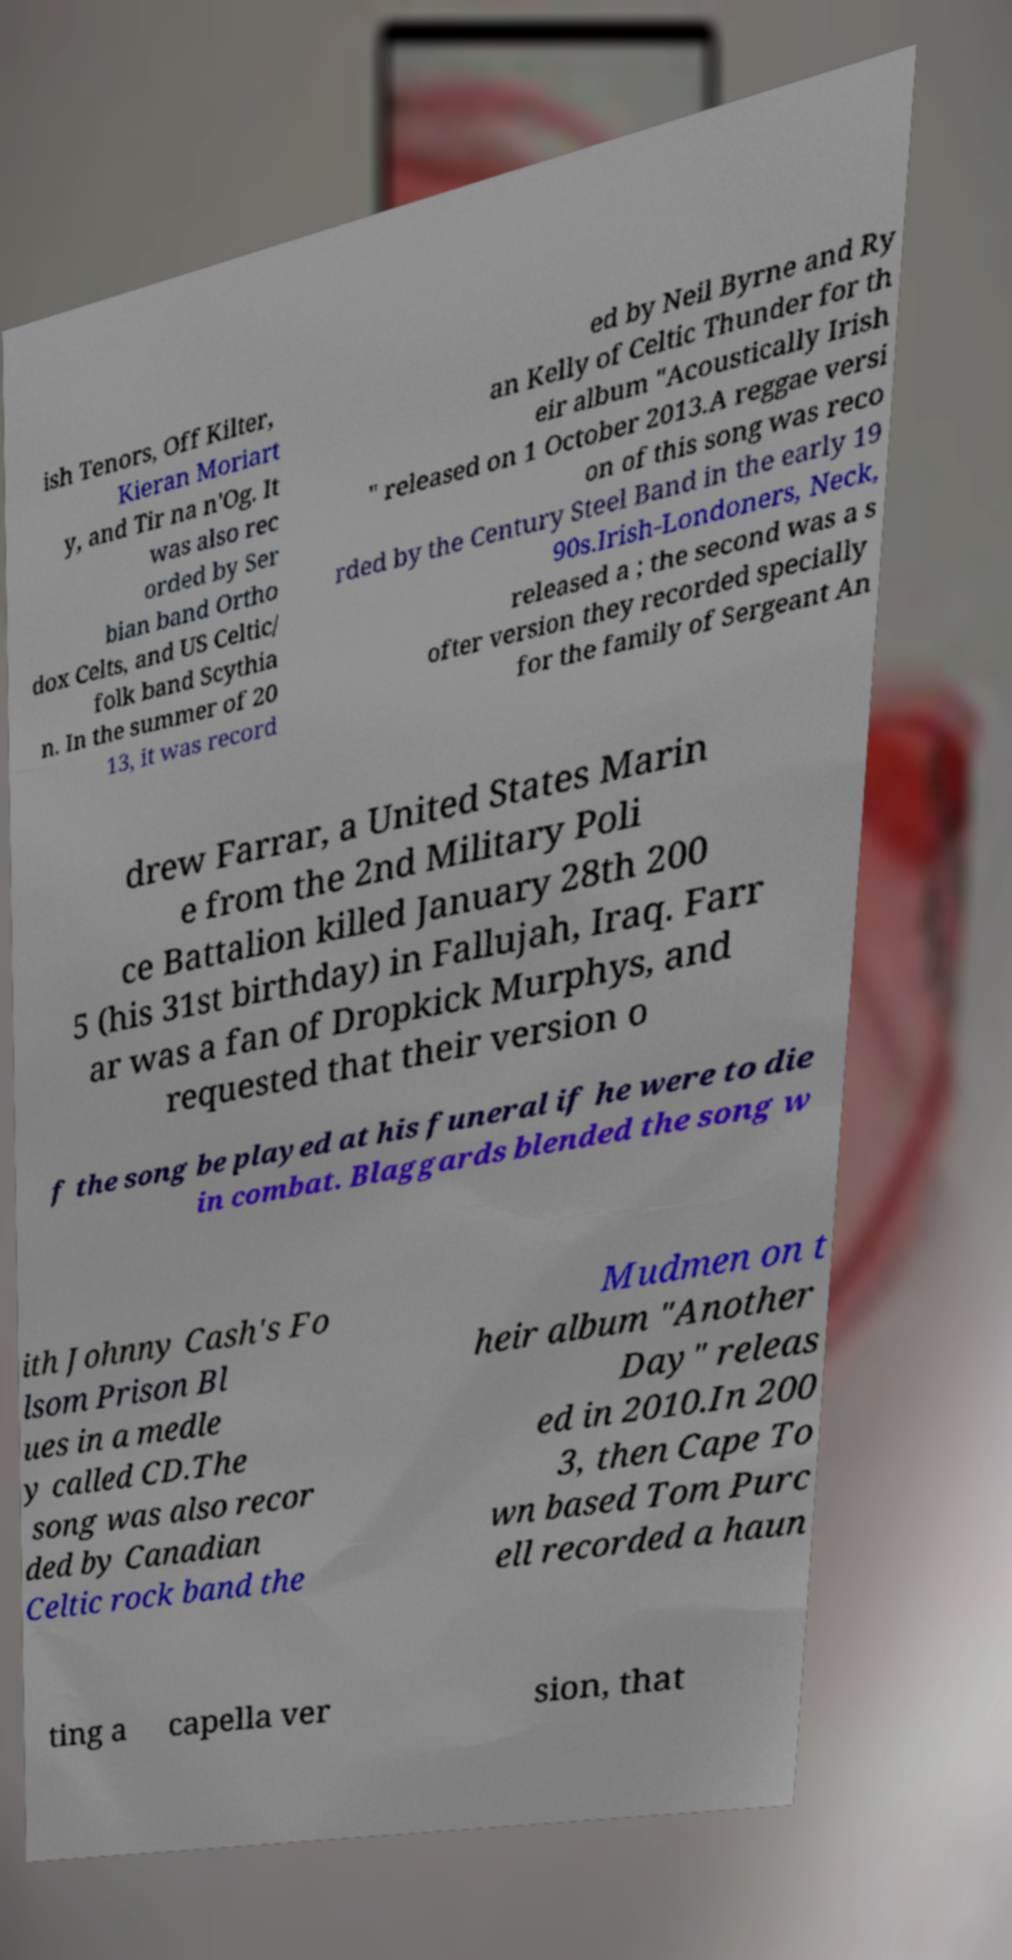Please read and relay the text visible in this image. What does it say? ish Tenors, Off Kilter, Kieran Moriart y, and Tir na n'Og. It was also rec orded by Ser bian band Ortho dox Celts, and US Celtic/ folk band Scythia n. In the summer of 20 13, it was record ed by Neil Byrne and Ry an Kelly of Celtic Thunder for th eir album "Acoustically Irish " released on 1 October 2013.A reggae versi on of this song was reco rded by the Century Steel Band in the early 19 90s.Irish-Londoners, Neck, released a ; the second was a s ofter version they recorded specially for the family of Sergeant An drew Farrar, a United States Marin e from the 2nd Military Poli ce Battalion killed January 28th 200 5 (his 31st birthday) in Fallujah, Iraq. Farr ar was a fan of Dropkick Murphys, and requested that their version o f the song be played at his funeral if he were to die in combat. Blaggards blended the song w ith Johnny Cash's Fo lsom Prison Bl ues in a medle y called CD.The song was also recor ded by Canadian Celtic rock band the Mudmen on t heir album "Another Day" releas ed in 2010.In 200 3, then Cape To wn based Tom Purc ell recorded a haun ting a capella ver sion, that 